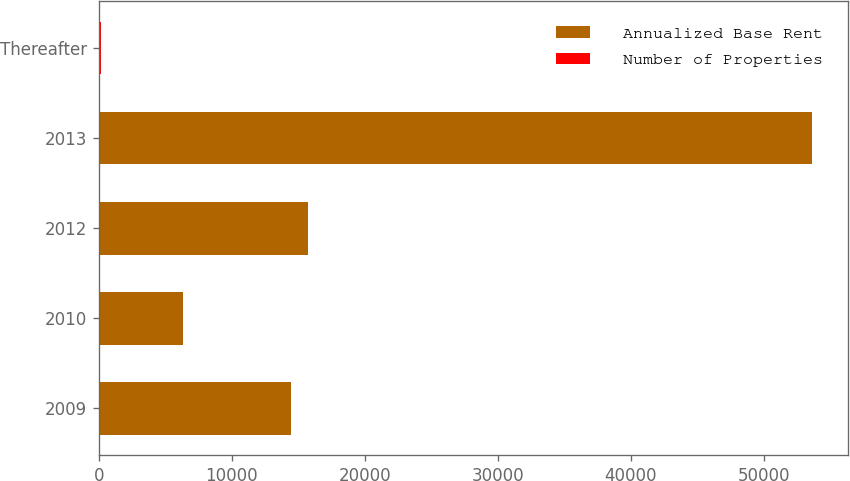<chart> <loc_0><loc_0><loc_500><loc_500><stacked_bar_chart><ecel><fcel>2009<fcel>2010<fcel>2012<fcel>2013<fcel>Thereafter<nl><fcel>Annualized Base Rent<fcel>14450<fcel>6321<fcel>15753<fcel>53628<fcel>68<nl><fcel>Number of Properties<fcel>7<fcel>2<fcel>2<fcel>22<fcel>68<nl></chart> 